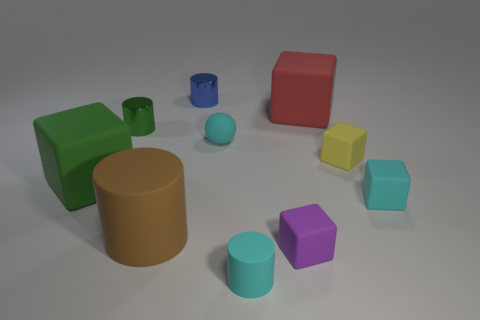Subtract 2 cubes. How many cubes are left? 3 Subtract all brown cylinders. Subtract all green spheres. How many cylinders are left? 3 Subtract all balls. How many objects are left? 9 Subtract all big yellow rubber blocks. Subtract all cyan rubber spheres. How many objects are left? 9 Add 1 large green cubes. How many large green cubes are left? 2 Add 4 tiny green metal things. How many tiny green metal things exist? 5 Subtract 0 gray balls. How many objects are left? 10 